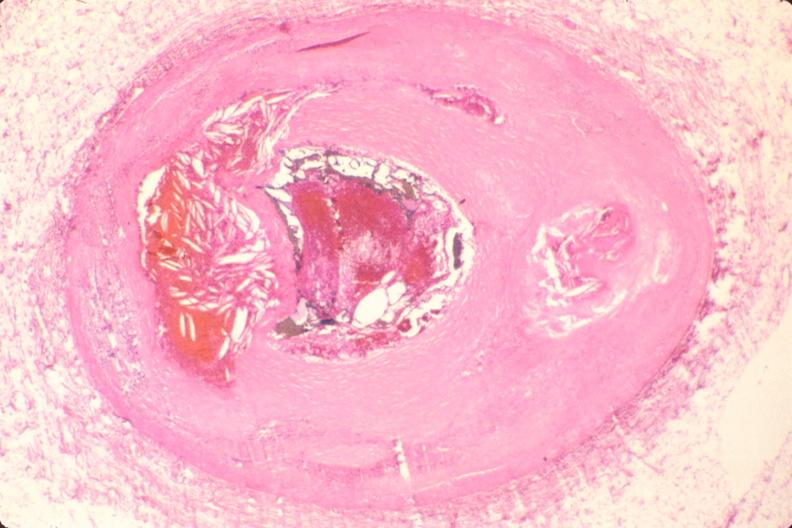does peritoneum show coronary artery atherosclerosis?
Answer the question using a single word or phrase. No 